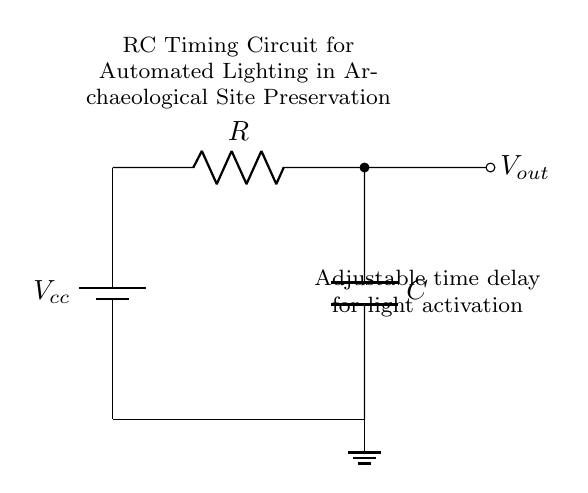What is the power supply in this circuit? The power supply is represented by the battery component labeled as Vcc. This is the source of voltage in the circuit.
Answer: Vcc What is the purpose of the resistor in the circuit? The resistor limits the current flowing through the circuit, affecting the charging rate of the capacitor. This is essential in determining the timing characteristics of the circuit.
Answer: Current limiting What is the output of the circuit? The output labeled as Vout represents the voltage across the capacitor, which is used to activate the lighting system.
Answer: Vout How do the resistor and capacitor together affect the timing? The time constant, represented by the product of resistance (R) and capacitance (C), determines how quickly the capacitor charges or discharges, thus controlling the time delay for activating the light.
Answer: Time constant What happens to the light activation when R increases? Increasing the resistance will increase the time constant, resulting in a longer time delay for the light to activate, as the capacitor will take longer to charge.
Answer: Longer delay What type of circuit is this? This is an RC timing circuit, specifically designed to delay an action—in this case, the activation of lighting in response to certain conditions.
Answer: RC timing circuit 